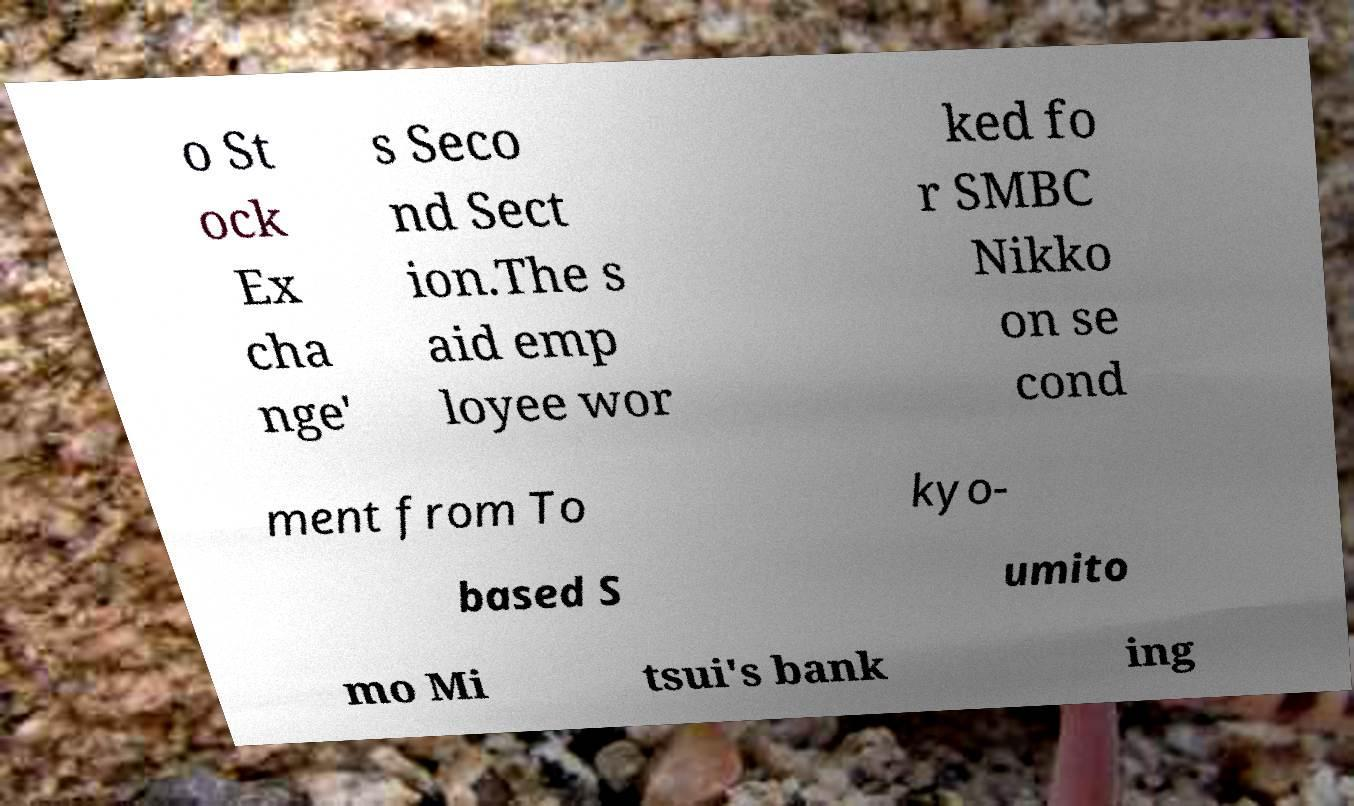Can you accurately transcribe the text from the provided image for me? o St ock Ex cha nge' s Seco nd Sect ion.The s aid emp loyee wor ked fo r SMBC Nikko on se cond ment from To kyo- based S umito mo Mi tsui's bank ing 